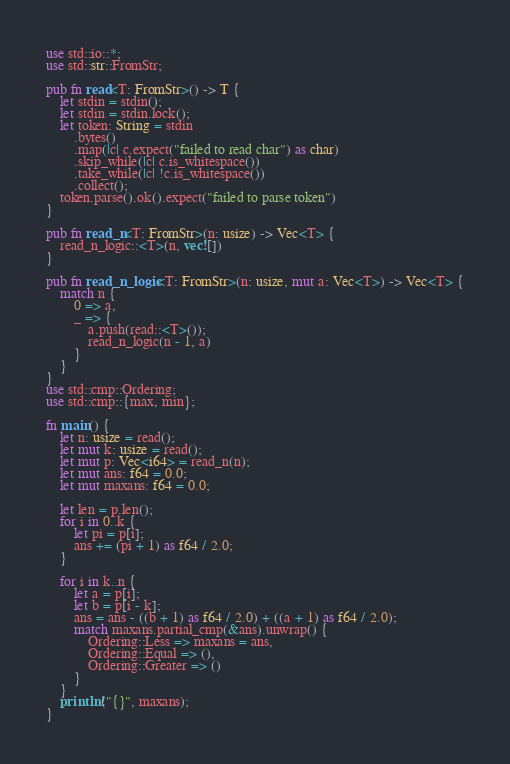<code> <loc_0><loc_0><loc_500><loc_500><_Rust_>use std::io::*;
use std::str::FromStr;

pub fn read<T: FromStr>() -> T {
    let stdin = stdin();
    let stdin = stdin.lock();
    let token: String = stdin
        .bytes()
        .map(|c| c.expect("failed to read char") as char)
        .skip_while(|c| c.is_whitespace())
        .take_while(|c| !c.is_whitespace())
        .collect();
    token.parse().ok().expect("failed to parse token")
}

pub fn read_n<T: FromStr>(n: usize) -> Vec<T> {
    read_n_logic::<T>(n, vec![])
}

pub fn read_n_logic<T: FromStr>(n: usize, mut a: Vec<T>) -> Vec<T> {
    match n {
        0 => a,
        _ => {
            a.push(read::<T>());
            read_n_logic(n - 1, a)
        }
    }
}
use std::cmp::Ordering;
use std::cmp::{max, min};

fn main() {
    let n: usize = read();
    let mut k: usize = read();
    let mut p: Vec<i64> = read_n(n);
    let mut ans: f64 = 0.0;
    let mut maxans: f64 = 0.0;

    let len = p.len();
    for i in 0..k {
        let pi = p[i];
        ans += (pi + 1) as f64 / 2.0;
    }

    for i in k..n {
        let a = p[i];
        let b = p[i - k];
        ans = ans - ((b + 1) as f64 / 2.0) + ((a + 1) as f64 / 2.0);
        match maxans.partial_cmp(&ans).unwrap() {
            Ordering::Less => maxans = ans,
            Ordering::Equal => (),
            Ordering::Greater => ()
        }
    }
    println!("{}", maxans);
}
</code> 